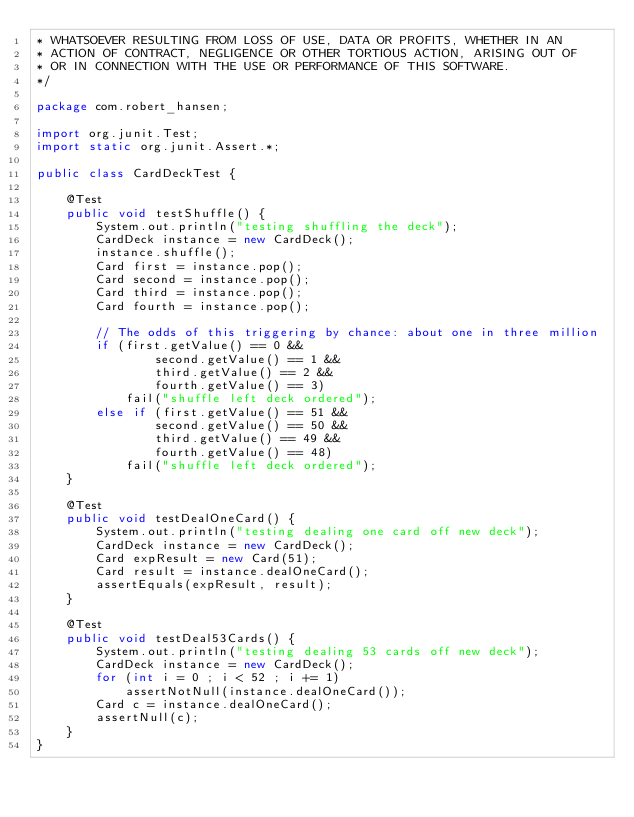Convert code to text. <code><loc_0><loc_0><loc_500><loc_500><_Java_>* WHATSOEVER RESULTING FROM LOSS OF USE, DATA OR PROFITS, WHETHER IN AN
* ACTION OF CONTRACT, NEGLIGENCE OR OTHER TORTIOUS ACTION, ARISING OUT OF
* OR IN CONNECTION WITH THE USE OR PERFORMANCE OF THIS SOFTWARE.
*/

package com.robert_hansen;

import org.junit.Test;
import static org.junit.Assert.*;

public class CardDeckTest {

    @Test
    public void testShuffle() {
        System.out.println("testing shuffling the deck");
        CardDeck instance = new CardDeck();
        instance.shuffle();
        Card first = instance.pop();
        Card second = instance.pop();
        Card third = instance.pop();
        Card fourth = instance.pop();
        
        // The odds of this triggering by chance: about one in three million
        if (first.getValue() == 0 &&
                second.getValue() == 1 && 
                third.getValue() == 2 &&
                fourth.getValue() == 3)
            fail("shuffle left deck ordered");
        else if (first.getValue() == 51 &&
                second.getValue() == 50 &&
                third.getValue() == 49 &&
                fourth.getValue() == 48)
            fail("shuffle left deck ordered");
    }

    @Test
    public void testDealOneCard() {
        System.out.println("testing dealing one card off new deck");
        CardDeck instance = new CardDeck();
        Card expResult = new Card(51);
        Card result = instance.dealOneCard();
        assertEquals(expResult, result);
    }
    
    @Test
    public void testDeal53Cards() {
        System.out.println("testing dealing 53 cards off new deck");
        CardDeck instance = new CardDeck();
        for (int i = 0 ; i < 52 ; i += 1)
            assertNotNull(instance.dealOneCard());
        Card c = instance.dealOneCard();
        assertNull(c);
    }
}
</code> 